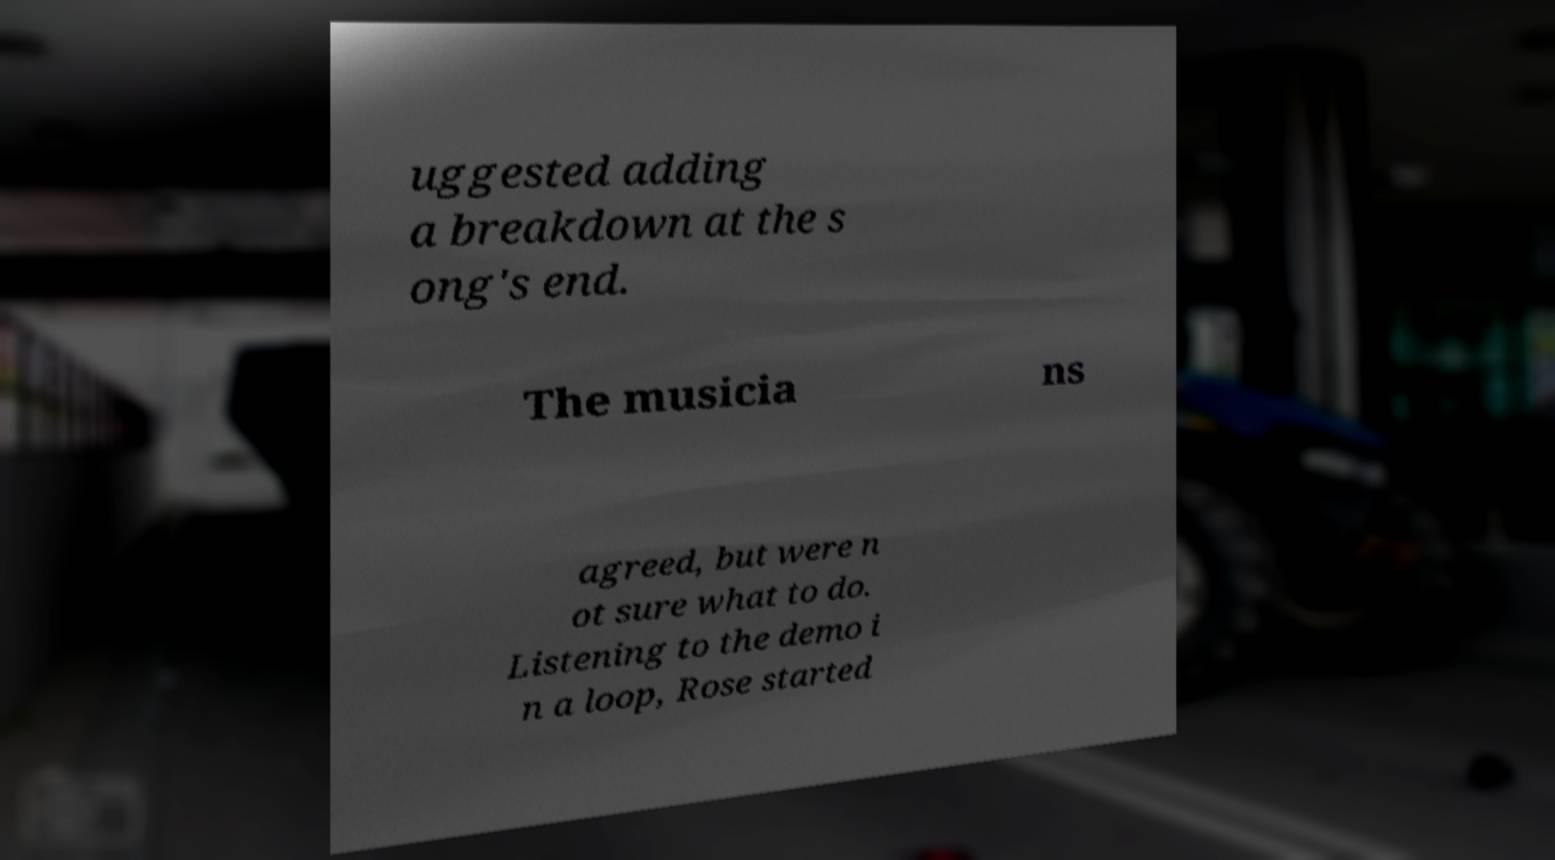For documentation purposes, I need the text within this image transcribed. Could you provide that? uggested adding a breakdown at the s ong's end. The musicia ns agreed, but were n ot sure what to do. Listening to the demo i n a loop, Rose started 